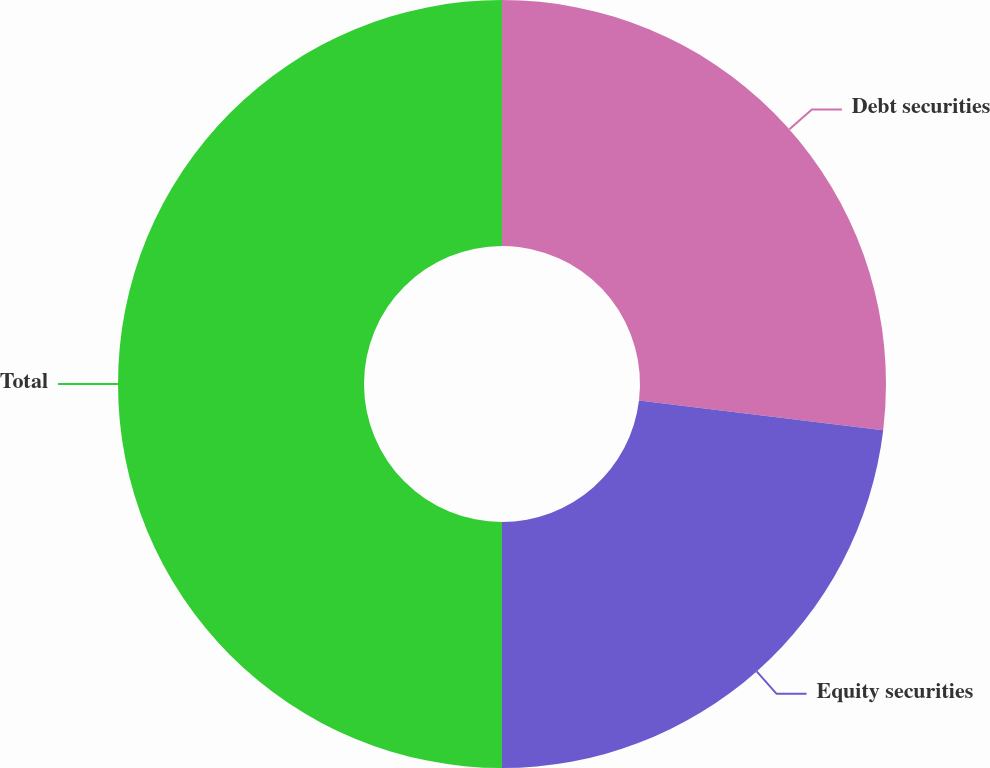Convert chart to OTSL. <chart><loc_0><loc_0><loc_500><loc_500><pie_chart><fcel>Debt securities<fcel>Equity securities<fcel>Total<nl><fcel>26.92%<fcel>23.08%<fcel>50.0%<nl></chart> 